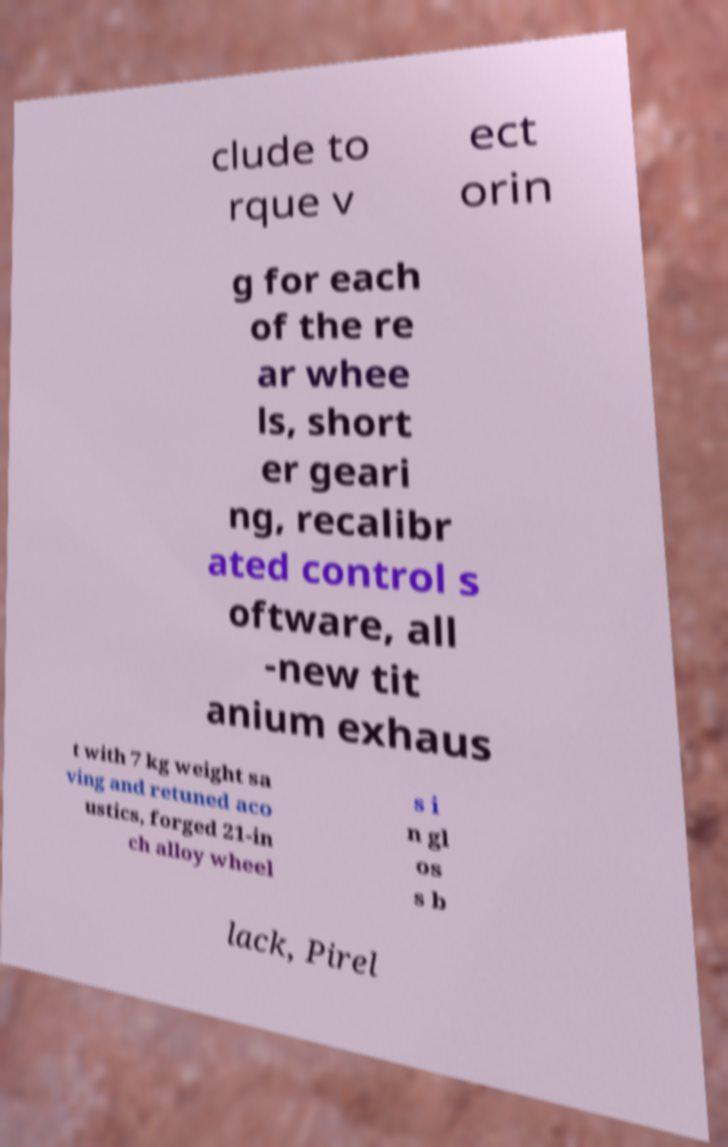I need the written content from this picture converted into text. Can you do that? clude to rque v ect orin g for each of the re ar whee ls, short er geari ng, recalibr ated control s oftware, all -new tit anium exhaus t with 7 kg weight sa ving and retuned aco ustics, forged 21-in ch alloy wheel s i n gl os s b lack, Pirel 